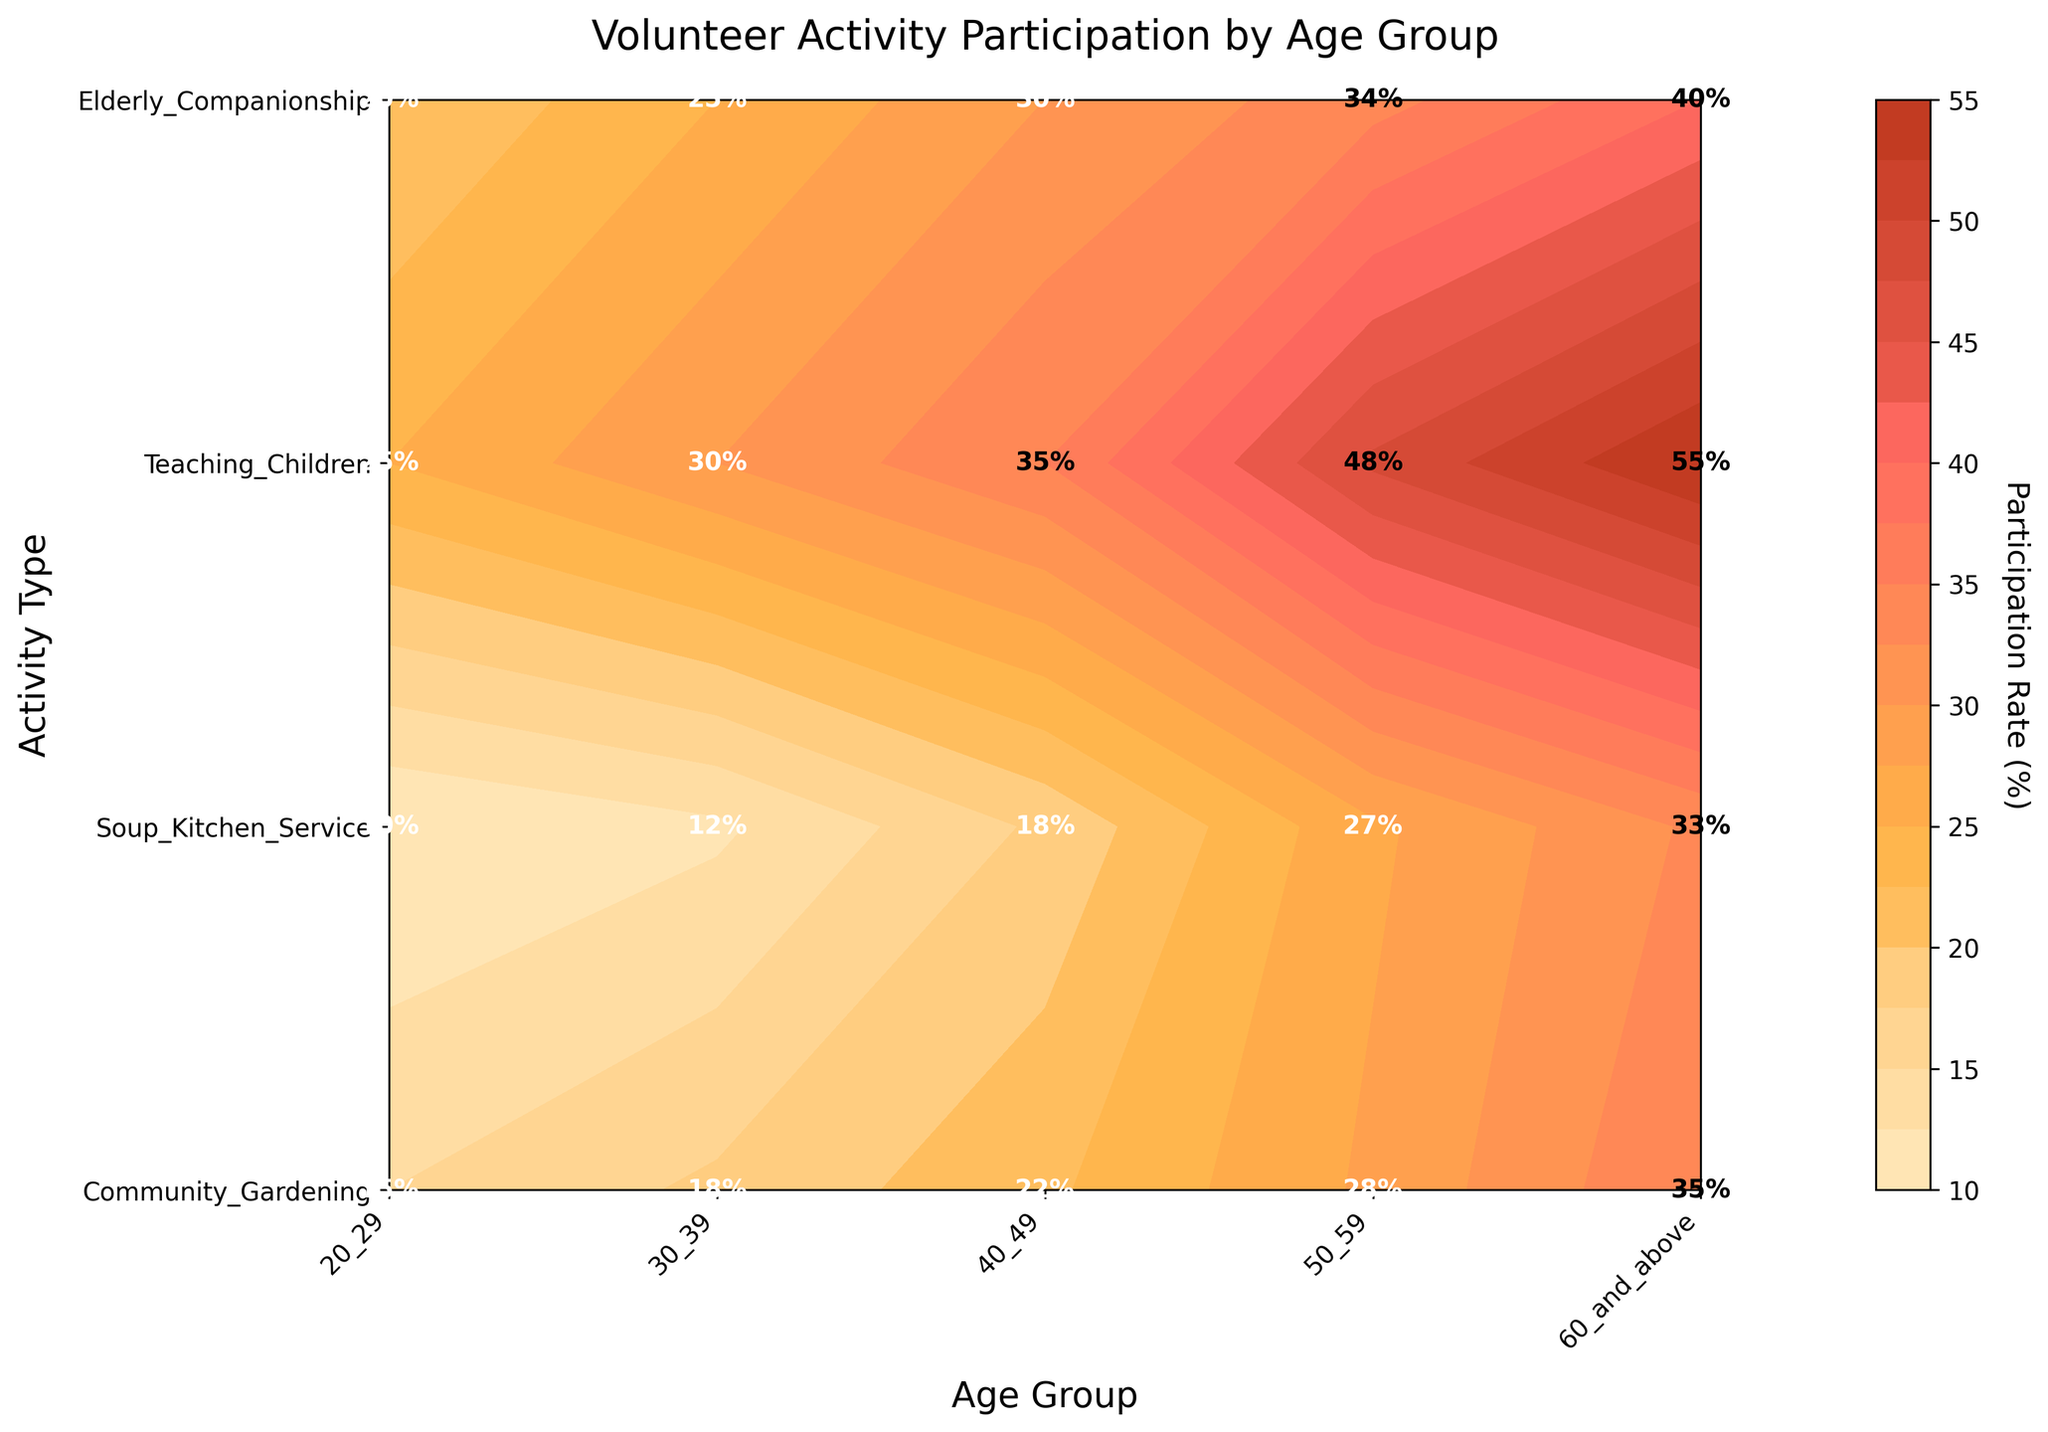What's the title of the figure? The title is usually located at the top of the figure and provides an overview of what the figure is representing. In this case, the title is directly stated in the code.
Answer: Volunteer Activity Participation by Age Group What is the participation rate for Community Gardening in the 50-59 age group? To find this, locate the 'Community Gardening' row and follow it to the column representing the '50-59' age group. The label inside the grid cell at this intersection shows the participation rate.
Answer: 28% Which activity has the highest participation rate in the 60 and above age group? First, find the column for '60 and above' age group, then look at the values within this column. Identify the maximum value and its corresponding activity in the row. The highest value in this column is 55% for 'Soup Kitchen Service'.
Answer: Soup Kitchen Service Compare the participation rate of Soup Kitchen Service and Elderly Companionship for the 40-49 age group. Which is higher and by how much? Find the row for 'Soup Kitchen Service' and 'Elderly Companionship', and look at the values under the '40-49' age group column. Subtract the participation rate of Elderly Companionship (18%) from that of Soup Kitchen Service (35%) to find the difference and confirm which is higher.
Answer: Soup Kitchen Service is higher by 17% What is the average participation rate for Teaching Children across all age groups? Locate the participation rates for 'Teaching Children' across all age groups: 20%, 25%, 30%, 34%, and 40%. Add these values together and divide by the number of age groups (5). The calculation is (20 + 25 + 30 + 34 + 40) / 5 = 29.8%.
Answer: 29.8% Which age group has the lowest participation rate in Elderly Companionship? Find the row for 'Elderly Companionship' and look at the participation rates across all age groups. Identify the minimum value and its corresponding age group, which is 10% in the '20-29' age group.
Answer: 20-29 Among all activities, which one has the most consistent participation rate increase with age? Look at the participation rates across different age groups for each activity and identify the one with a steady, gradual increase. 'Community Gardening' shows a consistent increase in values: 15%, 18%, 22%, 28%, 35%.
Answer: Community Gardening How does the participation rate of Community Gardening compare between the 20-29 and 60 and above age groups? Locate the values for 'Community Gardening' in the '20-29' and '60 and above' age groups, which are 15% and 35% respectively. Subtract the lower value from the higher value.
Answer: 60 and above is higher by 20% What is the difference in participation rates for Teaching Children between the 30-39 and 50-59 age groups? Find the row for 'Teaching Children' and compare the rates for '30-39' (25%) and '50-59' (34%) age groups. Calculate the difference by subtracting the smaller value from the larger value.
Answer: 9% 